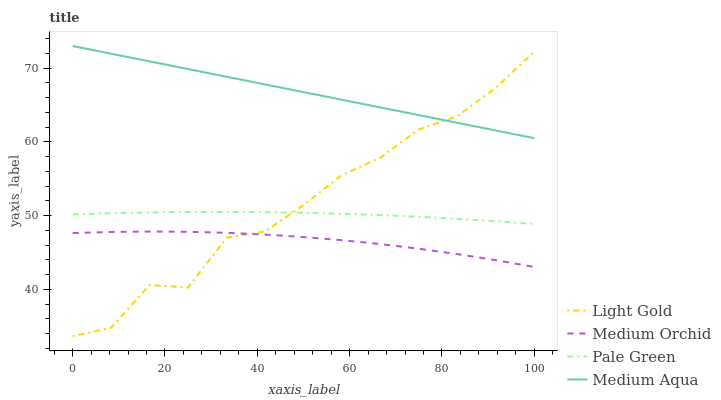Does Medium Orchid have the minimum area under the curve?
Answer yes or no. Yes. Does Medium Aqua have the maximum area under the curve?
Answer yes or no. Yes. Does Pale Green have the minimum area under the curve?
Answer yes or no. No. Does Pale Green have the maximum area under the curve?
Answer yes or no. No. Is Medium Aqua the smoothest?
Answer yes or no. Yes. Is Light Gold the roughest?
Answer yes or no. Yes. Is Pale Green the smoothest?
Answer yes or no. No. Is Pale Green the roughest?
Answer yes or no. No. Does Light Gold have the lowest value?
Answer yes or no. Yes. Does Pale Green have the lowest value?
Answer yes or no. No. Does Medium Aqua have the highest value?
Answer yes or no. Yes. Does Pale Green have the highest value?
Answer yes or no. No. Is Medium Orchid less than Pale Green?
Answer yes or no. Yes. Is Medium Aqua greater than Medium Orchid?
Answer yes or no. Yes. Does Light Gold intersect Medium Orchid?
Answer yes or no. Yes. Is Light Gold less than Medium Orchid?
Answer yes or no. No. Is Light Gold greater than Medium Orchid?
Answer yes or no. No. Does Medium Orchid intersect Pale Green?
Answer yes or no. No. 